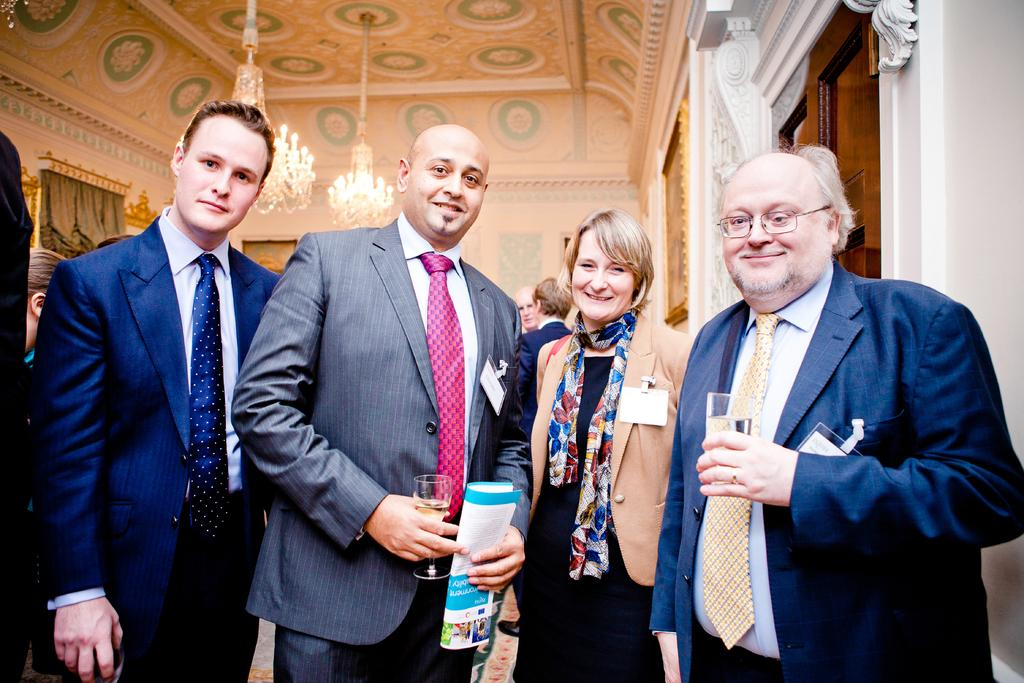How many people are in the image? There are four people standing in the image. What is the facial expression of the people in the image? The people are smiling. What are two of the men holding in the image? Two men are holding glasses. Can you describe the background of the image? The background of the image includes people, a ceiling, chandeliers, curtains, and frames. What type of dime is visible on the neck of one of the people in the image? There is no dime visible on the neck of any person in the image. How does the sponge contribute to the overall aesthetic of the image? There is no sponge present in the image. 